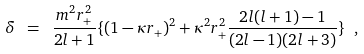Convert formula to latex. <formula><loc_0><loc_0><loc_500><loc_500>\delta \ = \ \frac { m ^ { 2 } r _ { + } ^ { 2 } } { 2 l + 1 } \{ ( 1 - \kappa r _ { + } ) ^ { 2 } + \kappa ^ { 2 } r _ { + } ^ { 2 } \frac { 2 l ( l + 1 ) - 1 } { ( 2 l - 1 ) ( 2 l + 3 ) } \} \ ,</formula> 